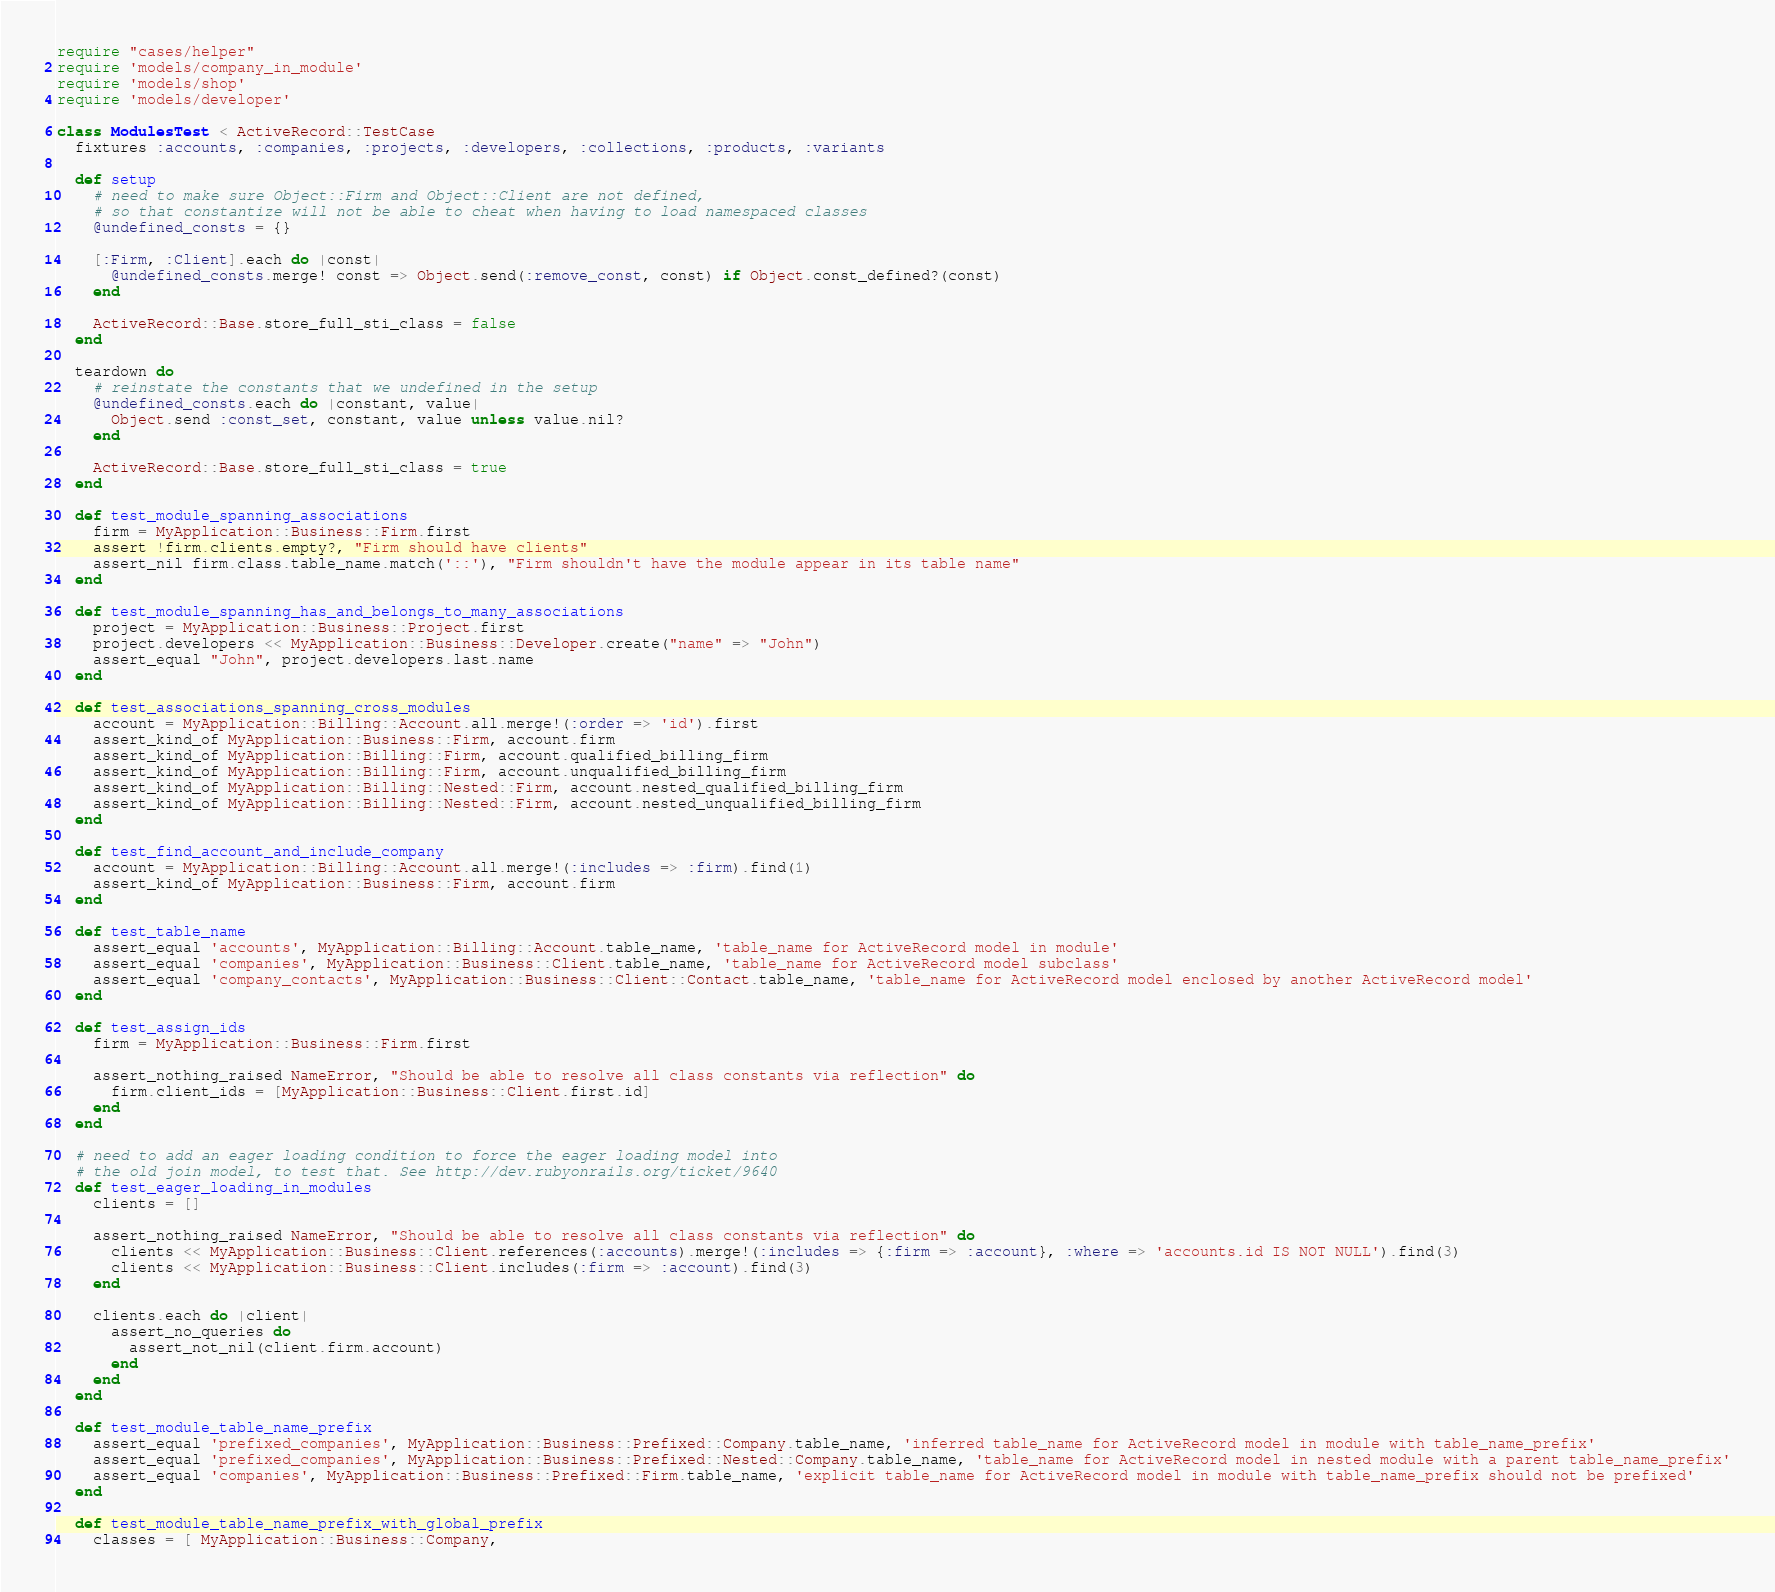<code> <loc_0><loc_0><loc_500><loc_500><_Ruby_>require "cases/helper"
require 'models/company_in_module'
require 'models/shop'
require 'models/developer'

class ModulesTest < ActiveRecord::TestCase
  fixtures :accounts, :companies, :projects, :developers, :collections, :products, :variants

  def setup
    # need to make sure Object::Firm and Object::Client are not defined,
    # so that constantize will not be able to cheat when having to load namespaced classes
    @undefined_consts = {}

    [:Firm, :Client].each do |const|
      @undefined_consts.merge! const => Object.send(:remove_const, const) if Object.const_defined?(const)
    end

    ActiveRecord::Base.store_full_sti_class = false
  end

  teardown do
    # reinstate the constants that we undefined in the setup
    @undefined_consts.each do |constant, value|
      Object.send :const_set, constant, value unless value.nil?
    end

    ActiveRecord::Base.store_full_sti_class = true
  end

  def test_module_spanning_associations
    firm = MyApplication::Business::Firm.first
    assert !firm.clients.empty?, "Firm should have clients"
    assert_nil firm.class.table_name.match('::'), "Firm shouldn't have the module appear in its table name"
  end

  def test_module_spanning_has_and_belongs_to_many_associations
    project = MyApplication::Business::Project.first
    project.developers << MyApplication::Business::Developer.create("name" => "John")
    assert_equal "John", project.developers.last.name
  end

  def test_associations_spanning_cross_modules
    account = MyApplication::Billing::Account.all.merge!(:order => 'id').first
    assert_kind_of MyApplication::Business::Firm, account.firm
    assert_kind_of MyApplication::Billing::Firm, account.qualified_billing_firm
    assert_kind_of MyApplication::Billing::Firm, account.unqualified_billing_firm
    assert_kind_of MyApplication::Billing::Nested::Firm, account.nested_qualified_billing_firm
    assert_kind_of MyApplication::Billing::Nested::Firm, account.nested_unqualified_billing_firm
  end

  def test_find_account_and_include_company
    account = MyApplication::Billing::Account.all.merge!(:includes => :firm).find(1)
    assert_kind_of MyApplication::Business::Firm, account.firm
  end

  def test_table_name
    assert_equal 'accounts', MyApplication::Billing::Account.table_name, 'table_name for ActiveRecord model in module'
    assert_equal 'companies', MyApplication::Business::Client.table_name, 'table_name for ActiveRecord model subclass'
    assert_equal 'company_contacts', MyApplication::Business::Client::Contact.table_name, 'table_name for ActiveRecord model enclosed by another ActiveRecord model'
  end

  def test_assign_ids
    firm = MyApplication::Business::Firm.first

    assert_nothing_raised NameError, "Should be able to resolve all class constants via reflection" do
      firm.client_ids = [MyApplication::Business::Client.first.id]
    end
  end

  # need to add an eager loading condition to force the eager loading model into
  # the old join model, to test that. See http://dev.rubyonrails.org/ticket/9640
  def test_eager_loading_in_modules
    clients = []

    assert_nothing_raised NameError, "Should be able to resolve all class constants via reflection" do
      clients << MyApplication::Business::Client.references(:accounts).merge!(:includes => {:firm => :account}, :where => 'accounts.id IS NOT NULL').find(3)
      clients << MyApplication::Business::Client.includes(:firm => :account).find(3)
    end

    clients.each do |client|
      assert_no_queries do
        assert_not_nil(client.firm.account)
      end
    end
  end

  def test_module_table_name_prefix
    assert_equal 'prefixed_companies', MyApplication::Business::Prefixed::Company.table_name, 'inferred table_name for ActiveRecord model in module with table_name_prefix'
    assert_equal 'prefixed_companies', MyApplication::Business::Prefixed::Nested::Company.table_name, 'table_name for ActiveRecord model in nested module with a parent table_name_prefix'
    assert_equal 'companies', MyApplication::Business::Prefixed::Firm.table_name, 'explicit table_name for ActiveRecord model in module with table_name_prefix should not be prefixed'
  end

  def test_module_table_name_prefix_with_global_prefix
    classes = [ MyApplication::Business::Company,</code> 